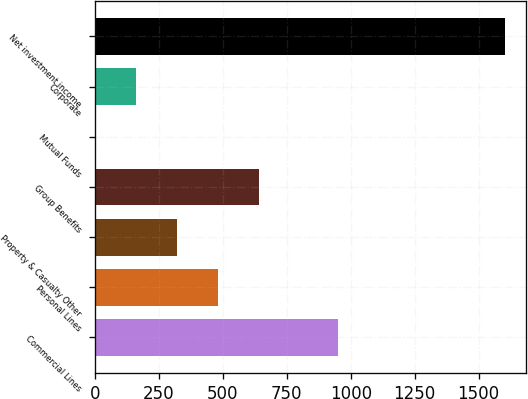Convert chart. <chart><loc_0><loc_0><loc_500><loc_500><bar_chart><fcel>Commercial Lines<fcel>Personal Lines<fcel>Property & Casualty Other<fcel>Group Benefits<fcel>Mutual Funds<fcel>Corporate<fcel>Net investment income<nl><fcel>949<fcel>483<fcel>323<fcel>643<fcel>3<fcel>163<fcel>1603<nl></chart> 